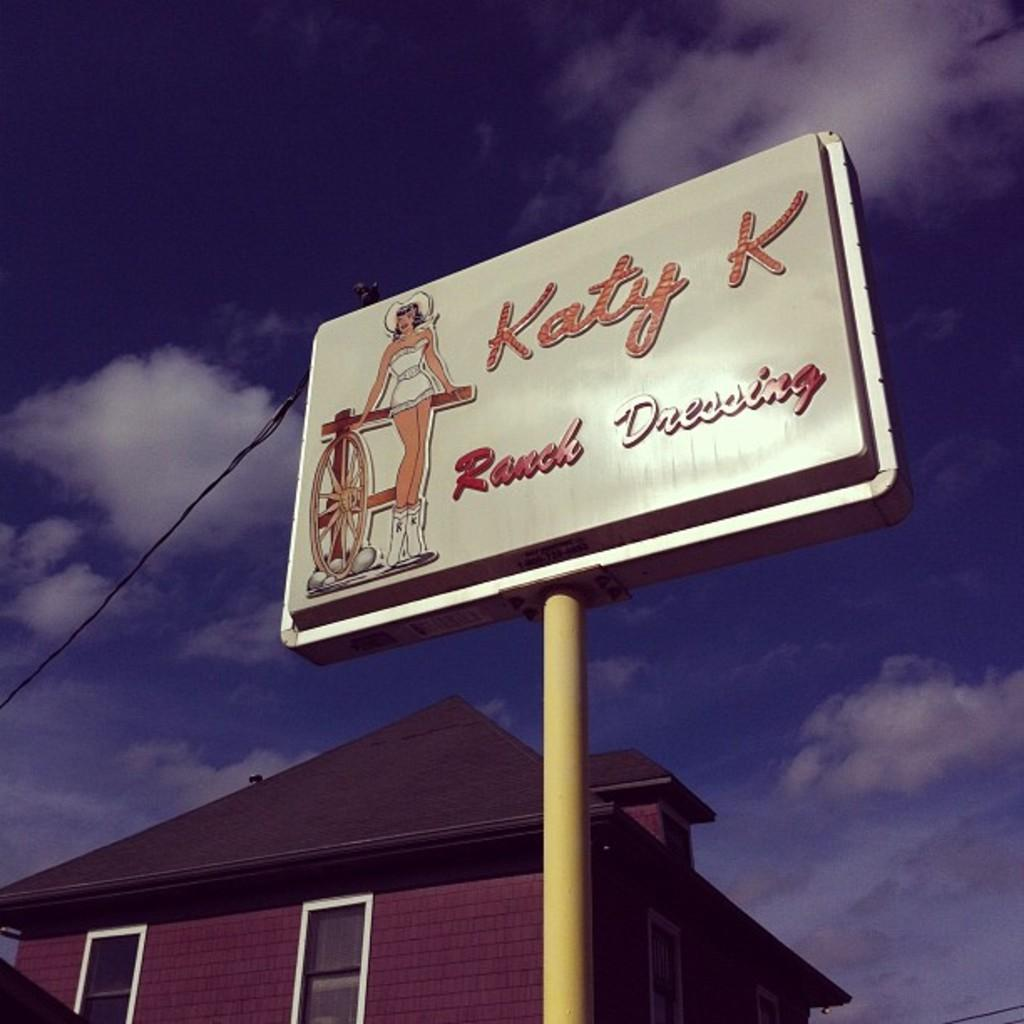Provide a one-sentence caption for the provided image. A store sign for KATY K Ranch dressing on a pole. 